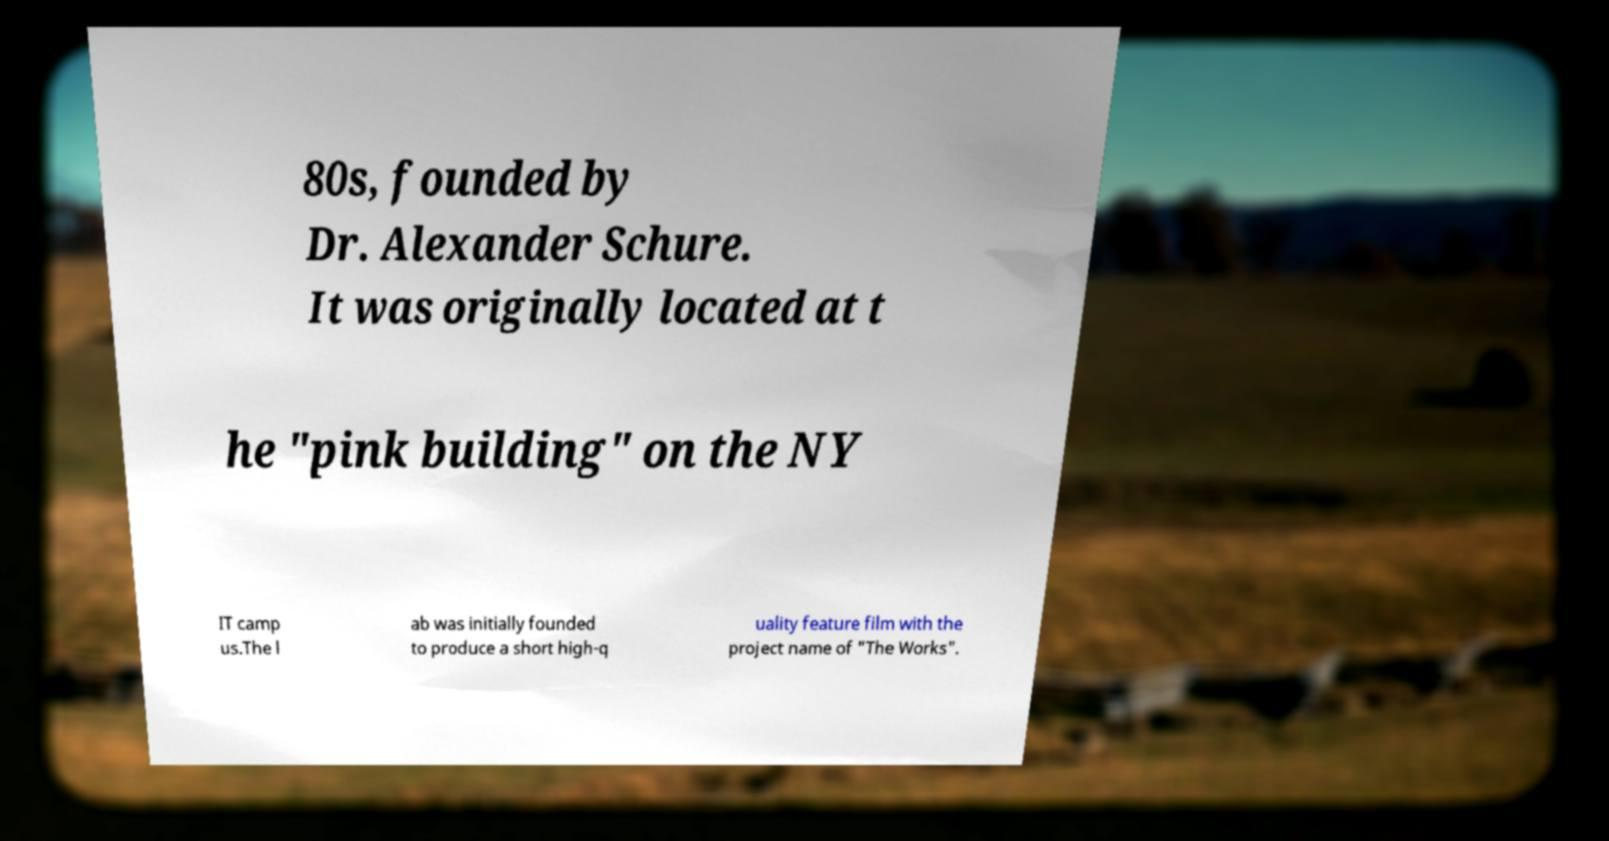Could you extract and type out the text from this image? 80s, founded by Dr. Alexander Schure. It was originally located at t he "pink building" on the NY IT camp us.The l ab was initially founded to produce a short high-q uality feature film with the project name of "The Works". 